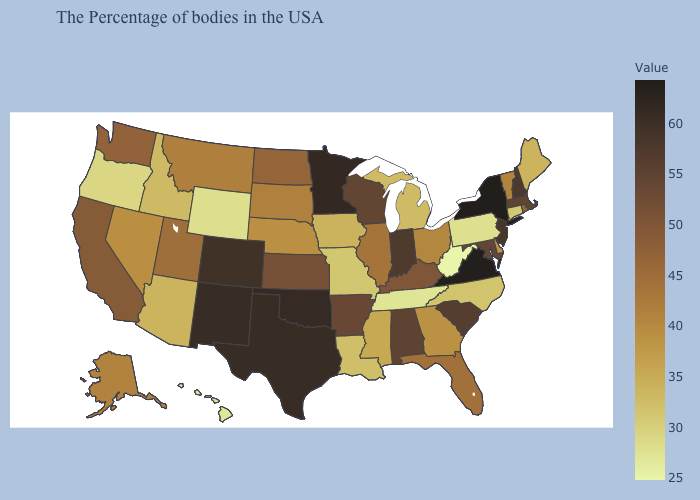Which states hav the highest value in the Northeast?
Keep it brief. New York. Is the legend a continuous bar?
Keep it brief. Yes. Among the states that border Pennsylvania , which have the lowest value?
Concise answer only. West Virginia. 